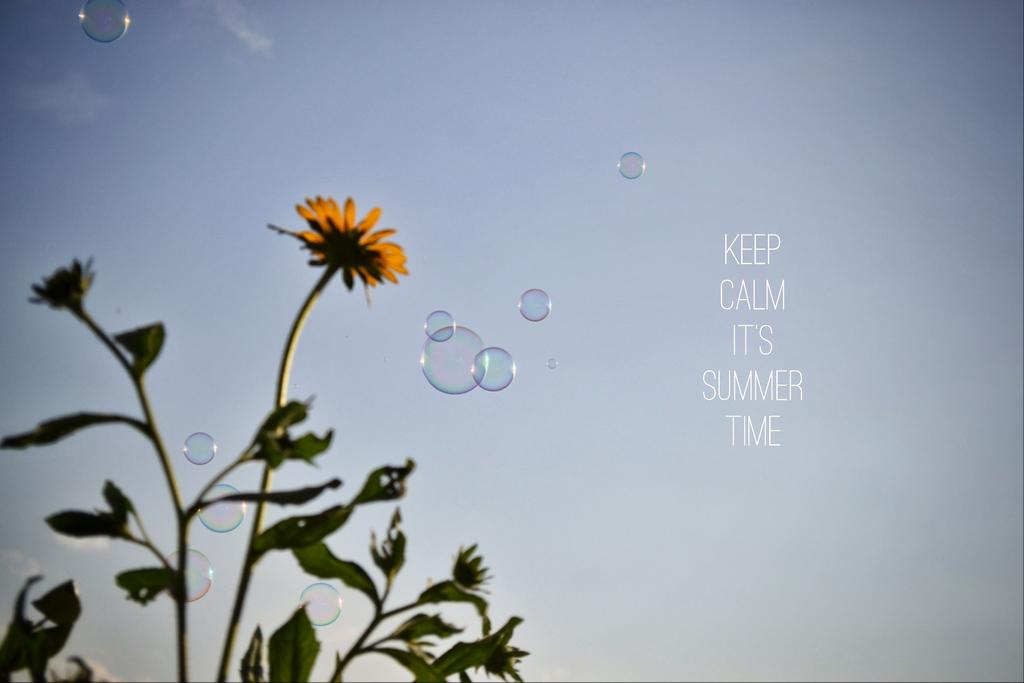What type of plant is in the image? There is a plant in the image, but the specific type cannot be determined from the facts provided. What is the plant holding or supporting? There is a flower in the image, which is likely on the plant. What else can be seen floating in the air in the image? There are bubbles in the air in the image. What can be seen in the distance in the image? There is a sky visible in the background of the image. What type of account does the plant have with the bank in the image? There is no mention of a bank or an account in the image, so this question cannot be answered. 